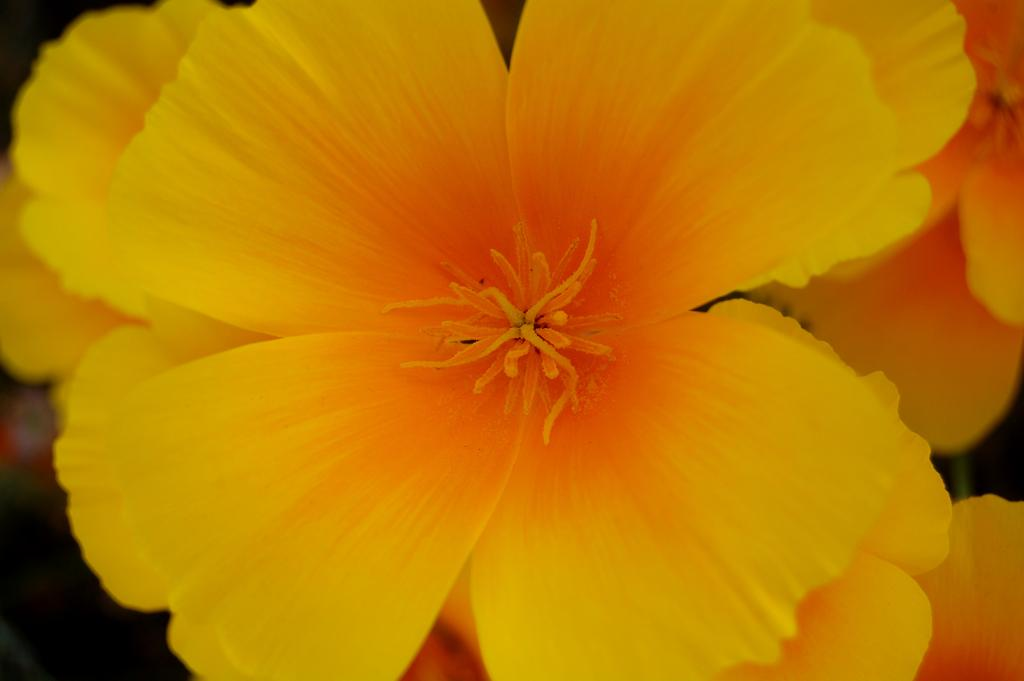What type of photography is used in the image? The image is a macro photography. What is the main subject of the macro photography? The subject of the macro photography is a yellow color flower. How many servants are attending to the flower in the image? There are no servants present in the image; it is a photograph of a flower. What color is the sink in the image? There is no sink present in the image; it is a macro photograph of a yellow flower. 